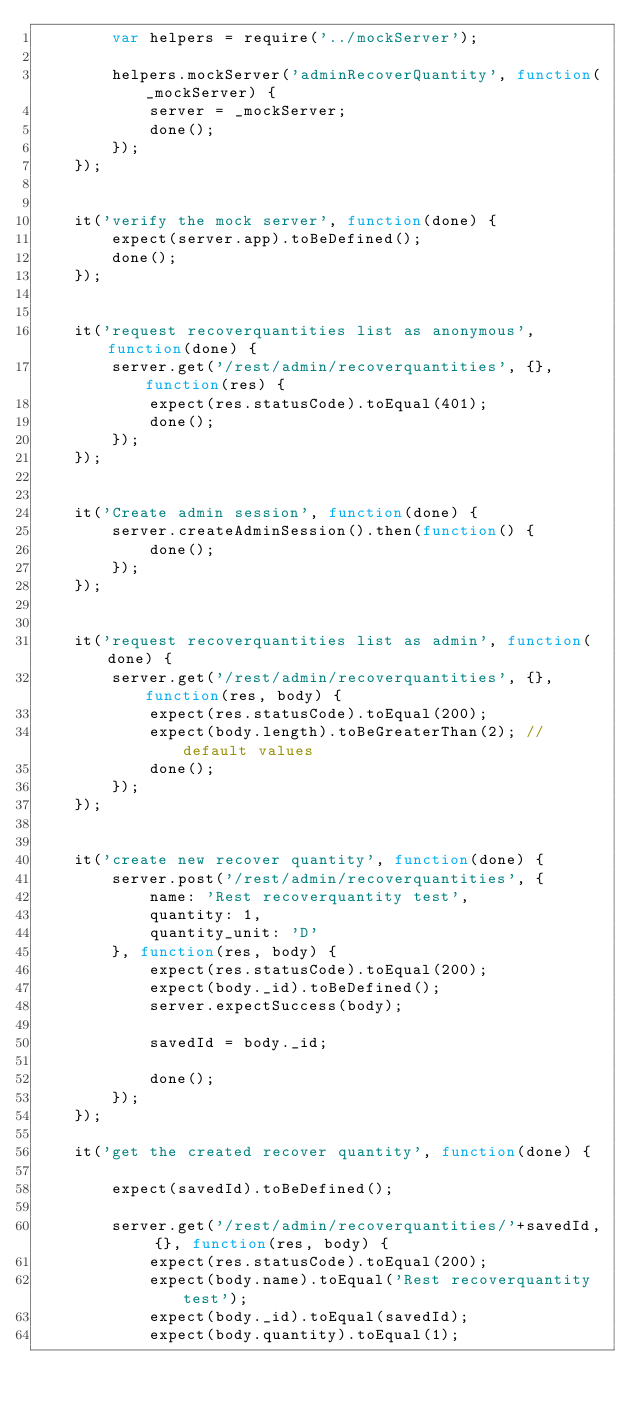Convert code to text. <code><loc_0><loc_0><loc_500><loc_500><_JavaScript_>        var helpers = require('../mockServer');

        helpers.mockServer('adminRecoverQuantity', function(_mockServer) {
            server = _mockServer;
            done();
        });
    });


    it('verify the mock server', function(done) {
        expect(server.app).toBeDefined();
        done();
    });


    it('request recoverquantities list as anonymous', function(done) {
        server.get('/rest/admin/recoverquantities', {}, function(res) {
            expect(res.statusCode).toEqual(401);
            done();
        });
    });


    it('Create admin session', function(done) {
        server.createAdminSession().then(function() {
            done();
        });
    });


    it('request recoverquantities list as admin', function(done) {
        server.get('/rest/admin/recoverquantities', {}, function(res, body) {
            expect(res.statusCode).toEqual(200);
            expect(body.length).toBeGreaterThan(2); // default values
            done();
        });
    });


    it('create new recover quantity', function(done) {
        server.post('/rest/admin/recoverquantities', {
            name: 'Rest recoverquantity test',
            quantity: 1,
            quantity_unit: 'D'
        }, function(res, body) {
            expect(res.statusCode).toEqual(200);
            expect(body._id).toBeDefined();
            server.expectSuccess(body);

            savedId = body._id;

            done();
        });
    });

    it('get the created recover quantity', function(done) {

        expect(savedId).toBeDefined();

        server.get('/rest/admin/recoverquantities/'+savedId, {}, function(res, body) {
            expect(res.statusCode).toEqual(200);
            expect(body.name).toEqual('Rest recoverquantity test');
            expect(body._id).toEqual(savedId);
            expect(body.quantity).toEqual(1);</code> 